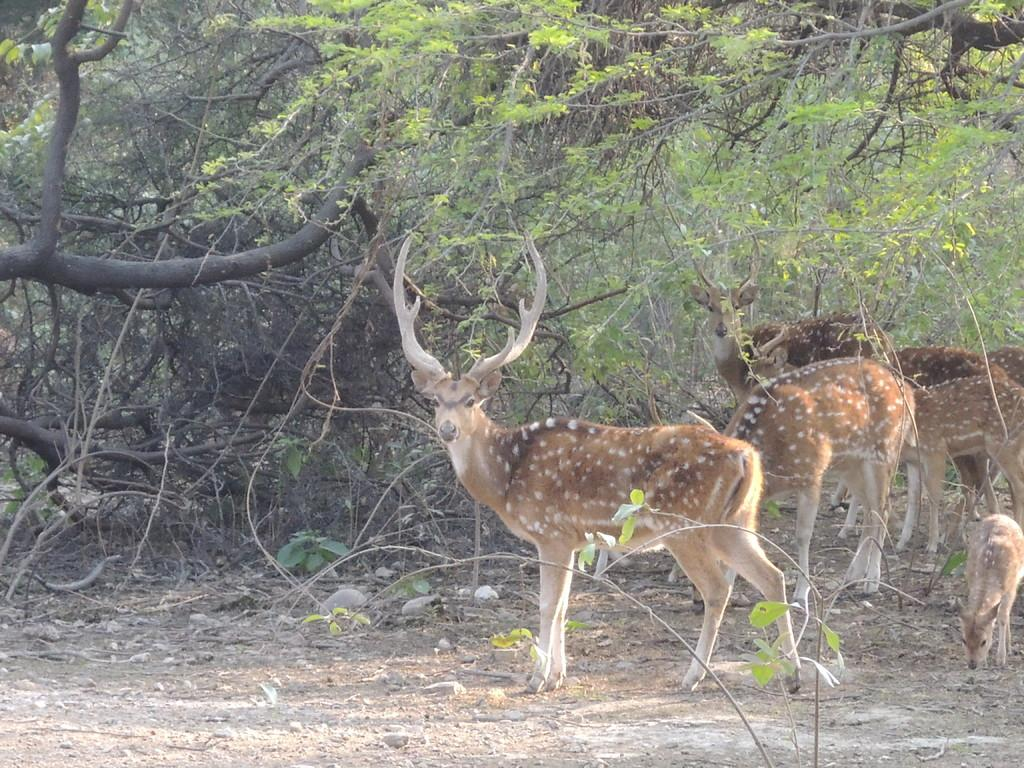What animals can be seen in the image? There are many deer in the image. What type of vegetation is visible in the background? There are trees in the background of the image. What is present on the ground in the image? There are stones on the ground in the image. Can you see a kitten playing with a foot in the image? There is no kitten or foot present in the image. 